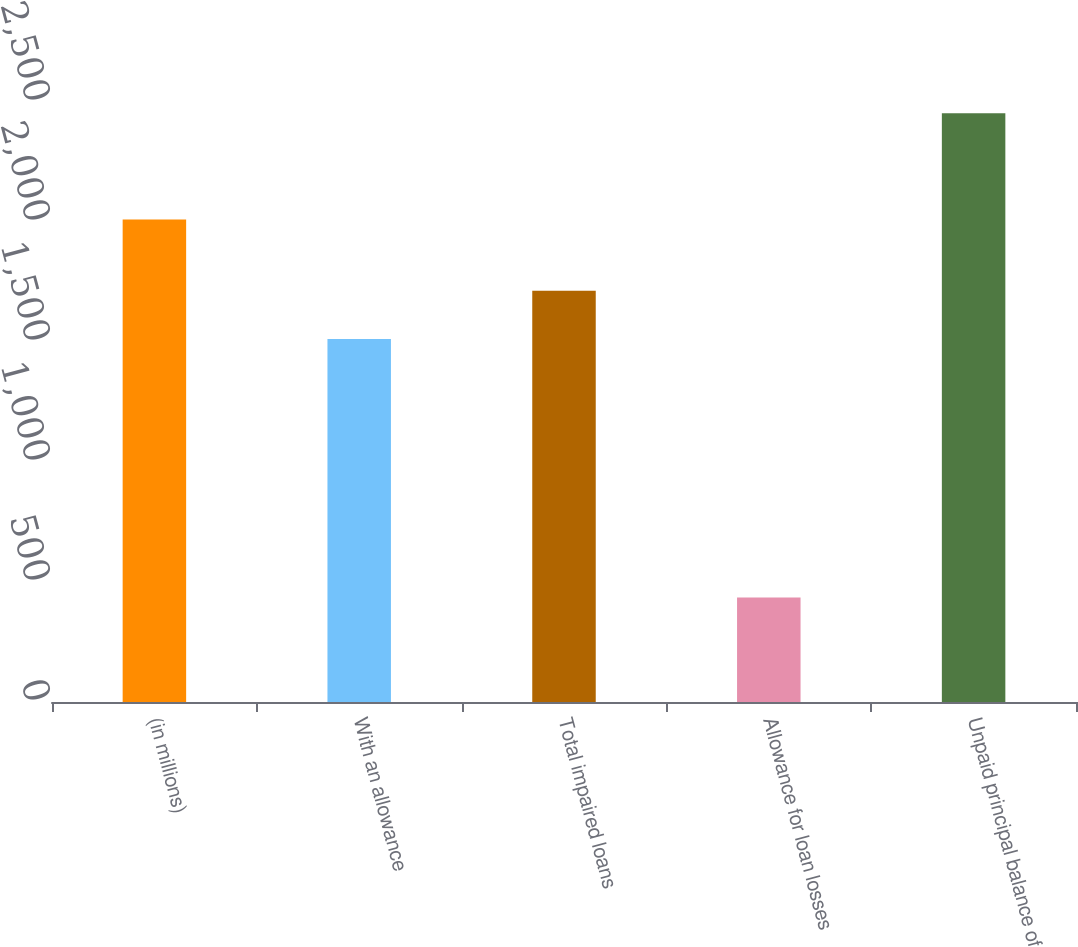Convert chart. <chart><loc_0><loc_0><loc_500><loc_500><bar_chart><fcel>(in millions)<fcel>With an allowance<fcel>Total impaired loans<fcel>Allowance for loan losses<fcel>Unpaid principal balance of<nl><fcel>2010<fcel>1512<fcel>1713.8<fcel>435<fcel>2453<nl></chart> 